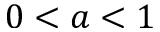Convert formula to latex. <formula><loc_0><loc_0><loc_500><loc_500>0 < a < 1</formula> 